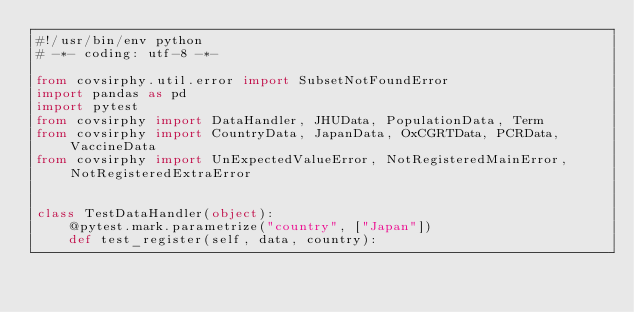Convert code to text. <code><loc_0><loc_0><loc_500><loc_500><_Python_>#!/usr/bin/env python
# -*- coding: utf-8 -*-

from covsirphy.util.error import SubsetNotFoundError
import pandas as pd
import pytest
from covsirphy import DataHandler, JHUData, PopulationData, Term
from covsirphy import CountryData, JapanData, OxCGRTData, PCRData, VaccineData
from covsirphy import UnExpectedValueError, NotRegisteredMainError, NotRegisteredExtraError


class TestDataHandler(object):
    @pytest.mark.parametrize("country", ["Japan"])
    def test_register(self, data, country):</code> 